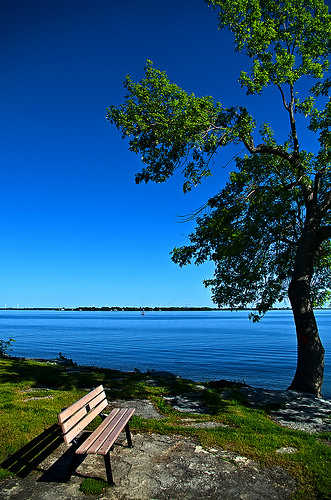<image>
Can you confirm if the tree is in the water? No. The tree is not contained within the water. These objects have a different spatial relationship. 